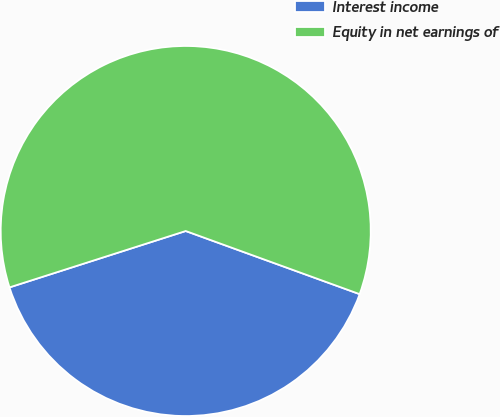<chart> <loc_0><loc_0><loc_500><loc_500><pie_chart><fcel>Interest income<fcel>Equity in net earnings of<nl><fcel>39.53%<fcel>60.47%<nl></chart> 